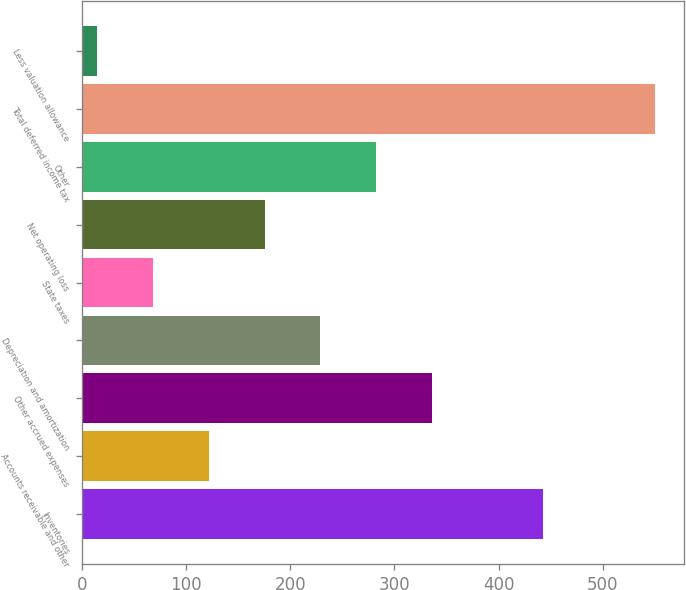Convert chart to OTSL. <chart><loc_0><loc_0><loc_500><loc_500><bar_chart><fcel>Inventories<fcel>Accounts receivable and other<fcel>Other accrued expenses<fcel>Depreciation and amortization<fcel>State taxes<fcel>Net operating loss<fcel>Other<fcel>Total deferred income tax<fcel>Less valuation allowance<nl><fcel>443.04<fcel>121.56<fcel>335.88<fcel>228.72<fcel>67.98<fcel>175.14<fcel>282.3<fcel>550.2<fcel>14.4<nl></chart> 